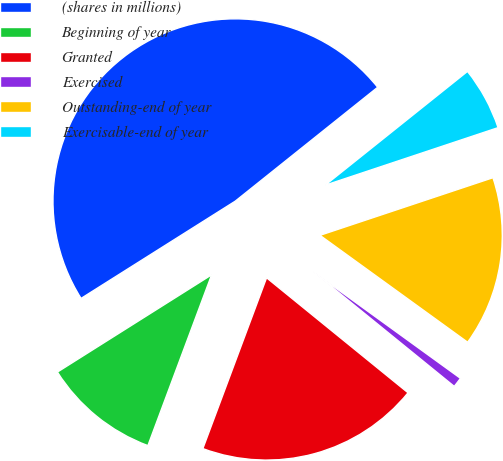Convert chart to OTSL. <chart><loc_0><loc_0><loc_500><loc_500><pie_chart><fcel>(shares in millions)<fcel>Beginning of year<fcel>Granted<fcel>Exercised<fcel>Outstanding-end of year<fcel>Exercisable-end of year<nl><fcel>48.22%<fcel>10.36%<fcel>19.82%<fcel>0.89%<fcel>15.09%<fcel>5.62%<nl></chart> 